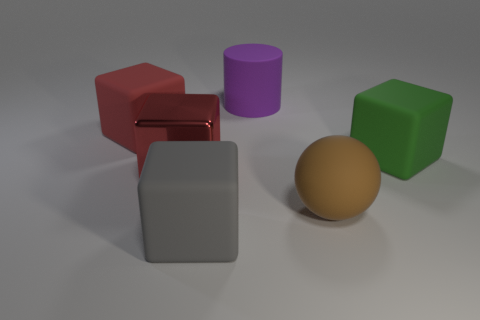What number of brown objects are either large rubber spheres or big cylinders?
Your answer should be compact. 1. There is a matte block that is in front of the cube that is on the right side of the rubber cylinder; what size is it?
Make the answer very short. Large. Is the color of the metallic thing the same as the thing in front of the brown object?
Ensure brevity in your answer.  No. How many other things are the same material as the gray cube?
Offer a terse response. 4. What is the shape of the large purple object that is the same material as the gray cube?
Offer a terse response. Cylinder. Are there any other things that have the same color as the large metal thing?
Provide a succinct answer. Yes. What is the size of the matte thing that is the same color as the shiny thing?
Your answer should be very brief. Large. Is the number of large green things in front of the sphere greater than the number of red things?
Provide a short and direct response. No. Does the brown matte thing have the same shape as the big thing in front of the sphere?
Make the answer very short. No. What number of other red matte blocks are the same size as the red rubber cube?
Offer a terse response. 0. 